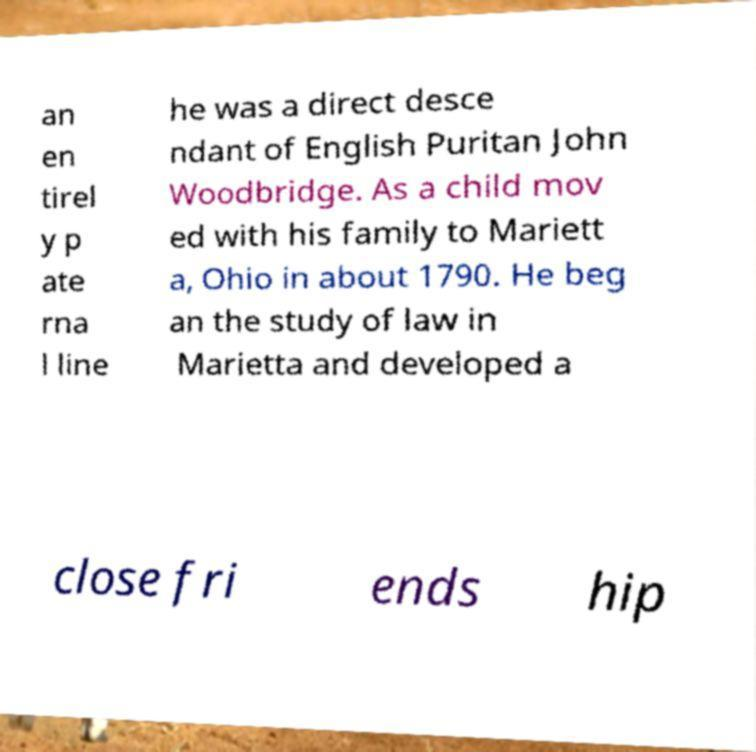What messages or text are displayed in this image? I need them in a readable, typed format. an en tirel y p ate rna l line he was a direct desce ndant of English Puritan John Woodbridge. As a child mov ed with his family to Mariett a, Ohio in about 1790. He beg an the study of law in Marietta and developed a close fri ends hip 